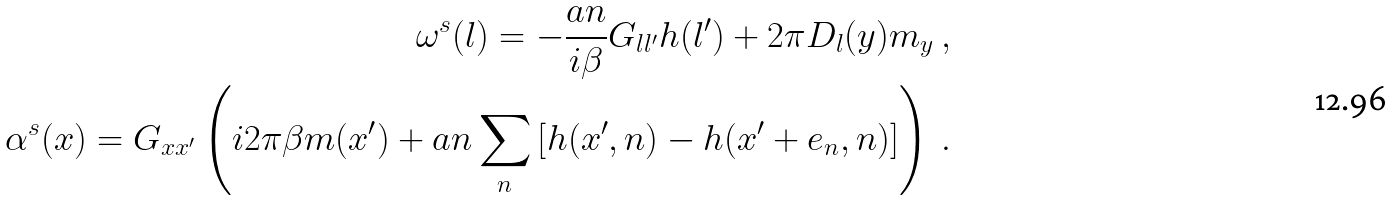<formula> <loc_0><loc_0><loc_500><loc_500>\omega ^ { s } ( l ) = - \frac { a n } { i \beta } G _ { l l ^ { \prime } } h ( l ^ { \prime } ) + 2 \pi D _ { l } ( y ) m _ { y } \ , \\ \alpha ^ { s } ( x ) = G _ { x x ^ { \prime } } \left ( i 2 \pi \beta m ( x ^ { \prime } ) + a n \sum _ { n } \left [ h ( x ^ { \prime } , n ) - h ( x ^ { \prime } + e _ { n } , n ) \right ] \right ) \ .</formula> 